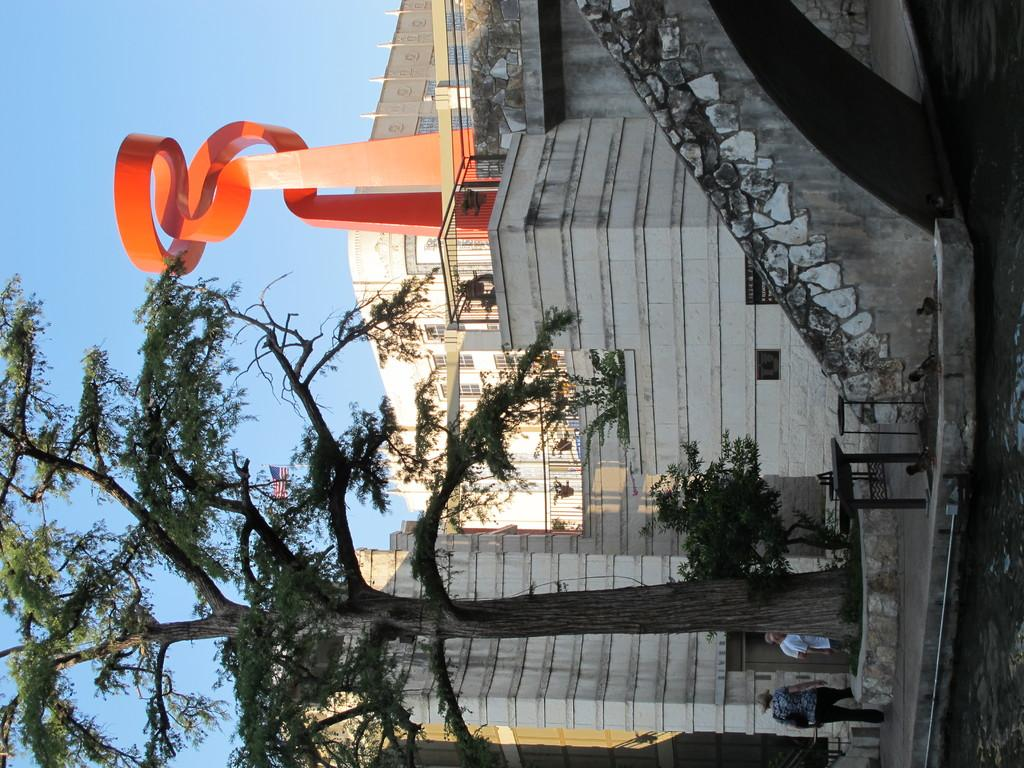What is the main subject in the center of the image? There is a house in the center of the image. What type of vegetation can be seen at the bottom side of the image? There is a tree at the bottom side of the image. What degree of difficulty is the tree climbing in the image? There is no indication of tree climbing in the image, so it is not possible to determine the degree of difficulty. 